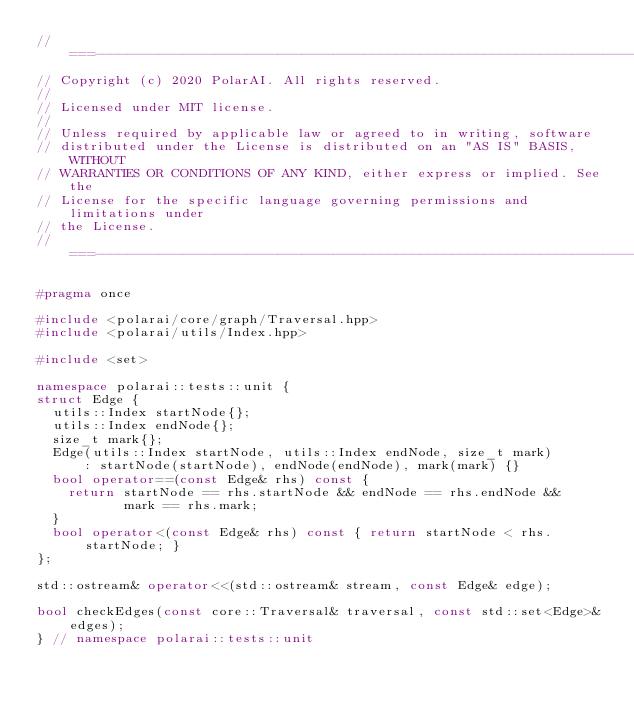Convert code to text. <code><loc_0><loc_0><loc_500><loc_500><_C++_>//===----------------------------------------------------------------------===//
// Copyright (c) 2020 PolarAI. All rights reserved.
//
// Licensed under MIT license.
//
// Unless required by applicable law or agreed to in writing, software
// distributed under the License is distributed on an "AS IS" BASIS, WITHOUT
// WARRANTIES OR CONDITIONS OF ANY KIND, either express or implied. See the
// License for the specific language governing permissions and limitations under
// the License.
//===----------------------------------------------------------------------===//

#pragma once

#include <polarai/core/graph/Traversal.hpp>
#include <polarai/utils/Index.hpp>

#include <set>

namespace polarai::tests::unit {
struct Edge {
  utils::Index startNode{};
  utils::Index endNode{};
  size_t mark{};
  Edge(utils::Index startNode, utils::Index endNode, size_t mark)
      : startNode(startNode), endNode(endNode), mark(mark) {}
  bool operator==(const Edge& rhs) const {
    return startNode == rhs.startNode && endNode == rhs.endNode &&
           mark == rhs.mark;
  }
  bool operator<(const Edge& rhs) const { return startNode < rhs.startNode; }
};

std::ostream& operator<<(std::ostream& stream, const Edge& edge);

bool checkEdges(const core::Traversal& traversal, const std::set<Edge>& edges);
} // namespace polarai::tests::unit
</code> 